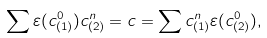<formula> <loc_0><loc_0><loc_500><loc_500>\sum \varepsilon ( c _ { ( 1 ) } ^ { 0 } ) c _ { ( 2 ) } ^ { n } = c = \sum c _ { ( 1 ) } ^ { n } \varepsilon ( c _ { ( 2 ) } ^ { 0 } ) ,</formula> 